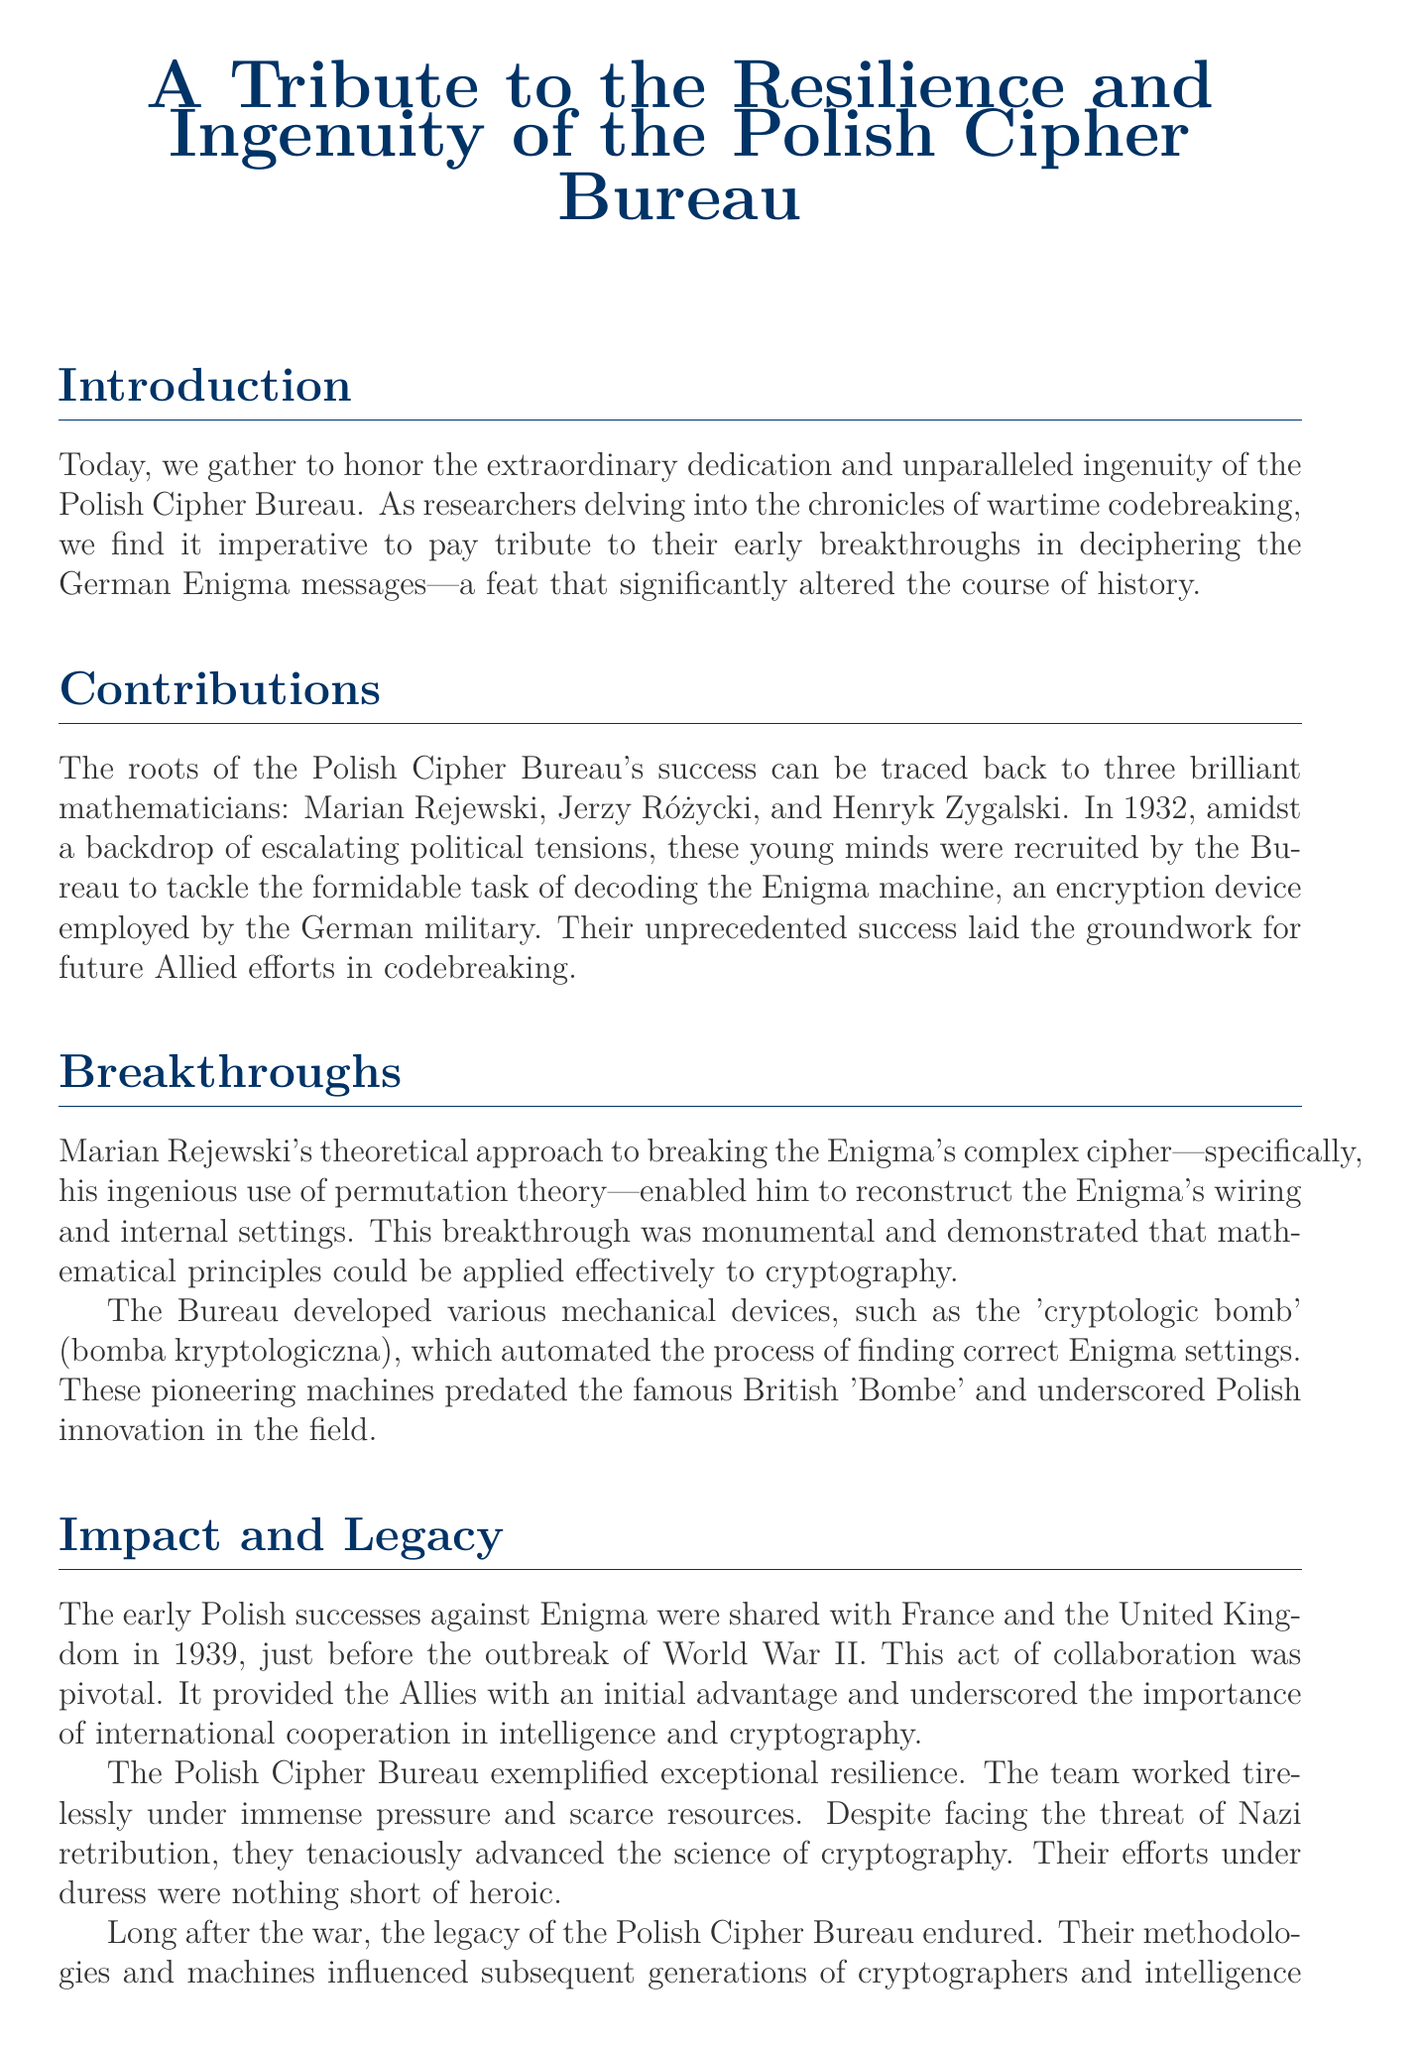what year did the Polish Cipher Bureau begin their work on the Enigma machine? The document states that the Polish Cipher Bureau was recruited in 1932 to decode the Enigma machine.
Answer: 1932 who were the three mathematicians mentioned in the document? The document lists Marian Rejewski, Jerzy Różycki, and Henryk Zygalski as the key figures of the Polish Cipher Bureau.
Answer: Marian Rejewski, Jerzy Różycki, and Henryk Zygalski what device did the Bureau develop to assist in breaking the Enigma code? The document mentions the 'cryptologic bomb' (bomba kryptologiczna) as a device developed by the Bureau.
Answer: cryptologic bomb which two countries did the Polish successes get shared with in 1939? The document refers to France and the United Kingdom as the countries that received information about Polish successes.
Answer: France and the United Kingdom what principle did Marian Rejewski use to break the Enigma cipher? The document notes that Rejewski's breakthrough involved the use of permutation theory.
Answer: permutation theory how did the Polish Cipher Bureau exemplify resilience? The document states that they worked tirelessly under immense pressure and scarce resources despite threats.
Answer: immense pressure and scarce resources what is the lasting impact of the Polish Cipher Bureau mentioned in the document? The document describes that their methodologies and machines influenced subsequent generations of cryptographers and intelligence agencies.
Answer: methodologies and machines what year marks the outbreak of World War II as referenced in the document? The document implies that the outbreak of WWII correlates with the sharing of Polish successes in 1939.
Answer: 1939 